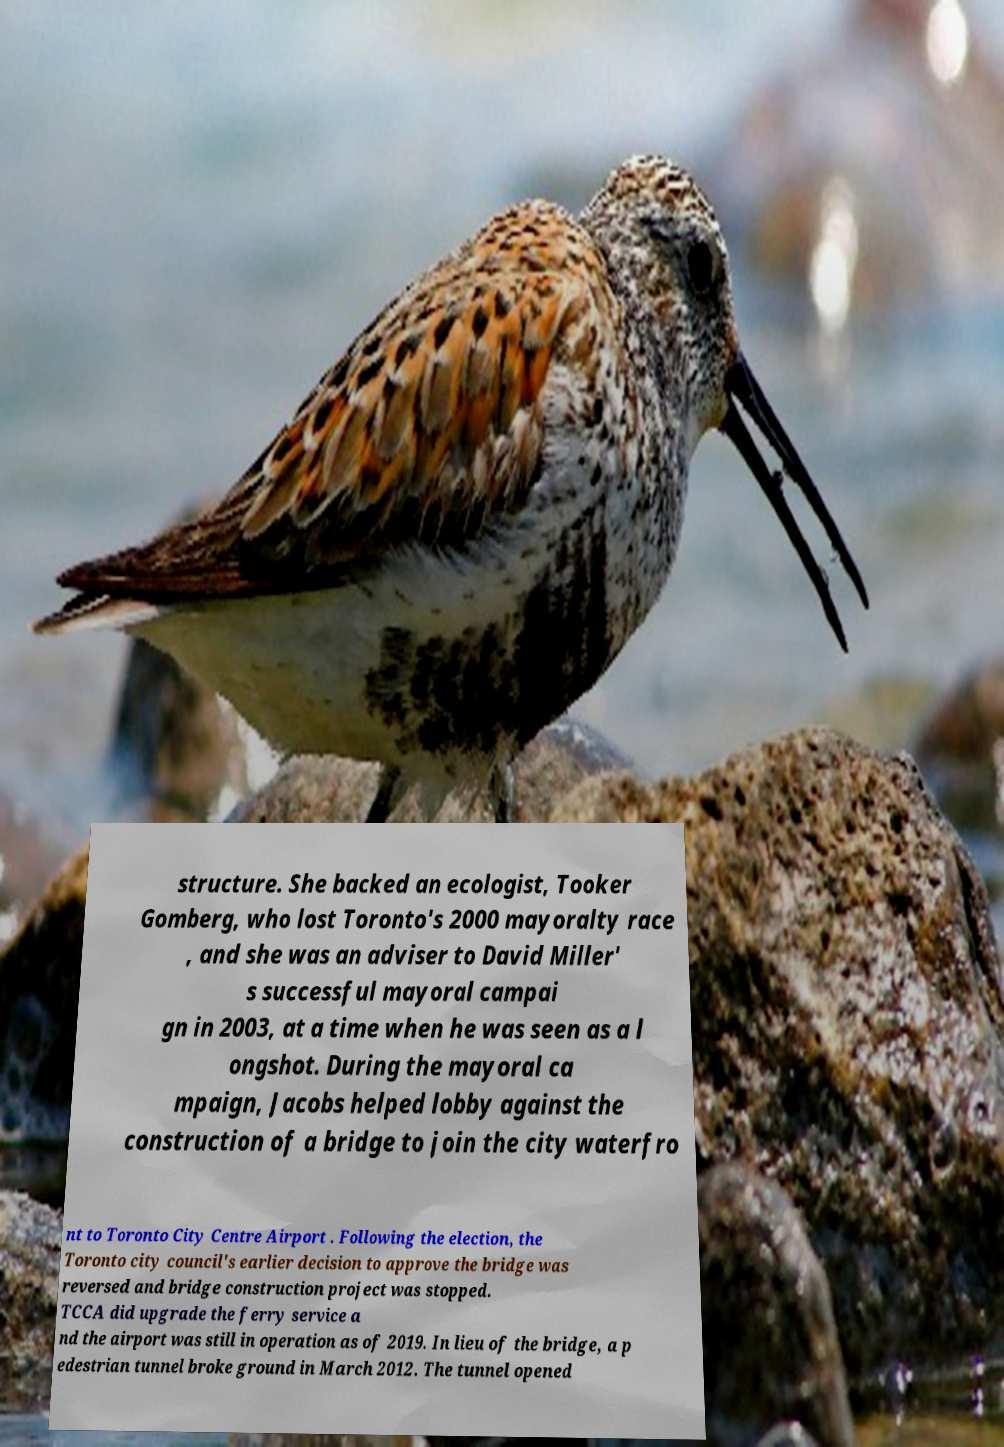Can you read and provide the text displayed in the image?This photo seems to have some interesting text. Can you extract and type it out for me? structure. She backed an ecologist, Tooker Gomberg, who lost Toronto's 2000 mayoralty race , and she was an adviser to David Miller' s successful mayoral campai gn in 2003, at a time when he was seen as a l ongshot. During the mayoral ca mpaign, Jacobs helped lobby against the construction of a bridge to join the city waterfro nt to Toronto City Centre Airport . Following the election, the Toronto city council's earlier decision to approve the bridge was reversed and bridge construction project was stopped. TCCA did upgrade the ferry service a nd the airport was still in operation as of 2019. In lieu of the bridge, a p edestrian tunnel broke ground in March 2012. The tunnel opened 